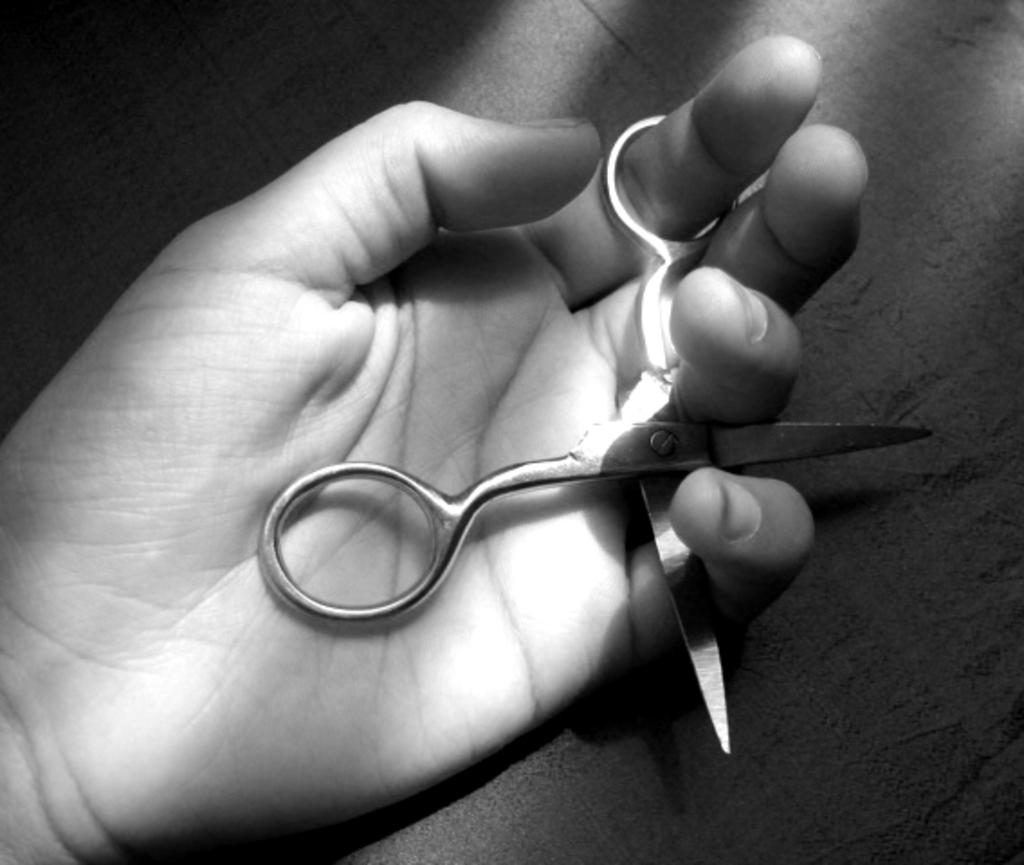What can be seen in the image related to a person's hand? There is a person's hand in the image. What is the hand holding? The hand is holding scissors. What type of sleet can be seen falling in the image? There is no sleet present in the image; it only shows a hand holding scissors. 